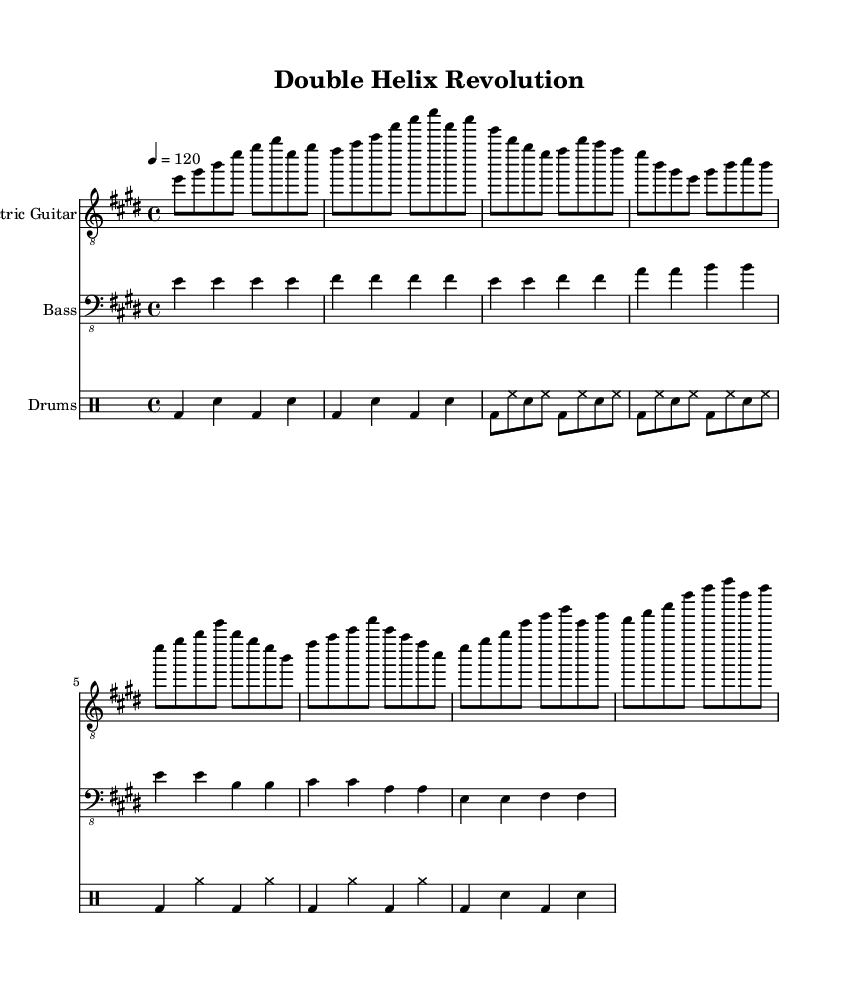What is the key signature of this music? The key signature is indicated by the number of sharps or flats at the beginning of the staff. In this case, the music is in E major, which has four sharps (F#, C#, G#, D#).
Answer: E major What is the time signature of this music? The time signature is shown at the beginning of the score, specifying how many beats are in each measure and what note value is considered one beat. Here, the time signature is 4/4, meaning there are four beats per measure, and the quarter note gets one beat.
Answer: 4/4 What is the tempo marking for this music? The tempo marking appears in the score and indicates the speed of the music, usually given in beats per minute. In this sheet music, the tempo marking is "4 = 120," meaning there are 120 beats per minute.
Answer: 120 How many measures are in the verse section? By counting the measures explicitly written in the verse section of the sheet music, we see there are four measures in total. This is determined by examining the notations in the verse block.
Answer: 4 What instrument plays the main melody in this piece? The main melody is typically found in the staff that is designated as "Electric Guitar," which is where the main notes for the tune are located. Since this staff has the most prominent melodic writing, it identifies the electric guitar as the principal instrument.
Answer: Electric Guitar What is the pattern of the chorus in terms of chord progressions? The chorus follows a specific chord progression in the written music indicating how the chords move within the measures. In this instance, the chorus alternates between the E major and B major chords, resulting in a structured pattern that provides a rock anthem feel.
Answer: E major to B major How many lines are used on the bass guitar staff? The bass guitar staff in this score uses a standard notation system with five lines. These lines serve to place the notes according to their pitch, consistent with typical bass guitar notation.
Answer: 5 